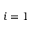<formula> <loc_0><loc_0><loc_500><loc_500>i = 1</formula> 